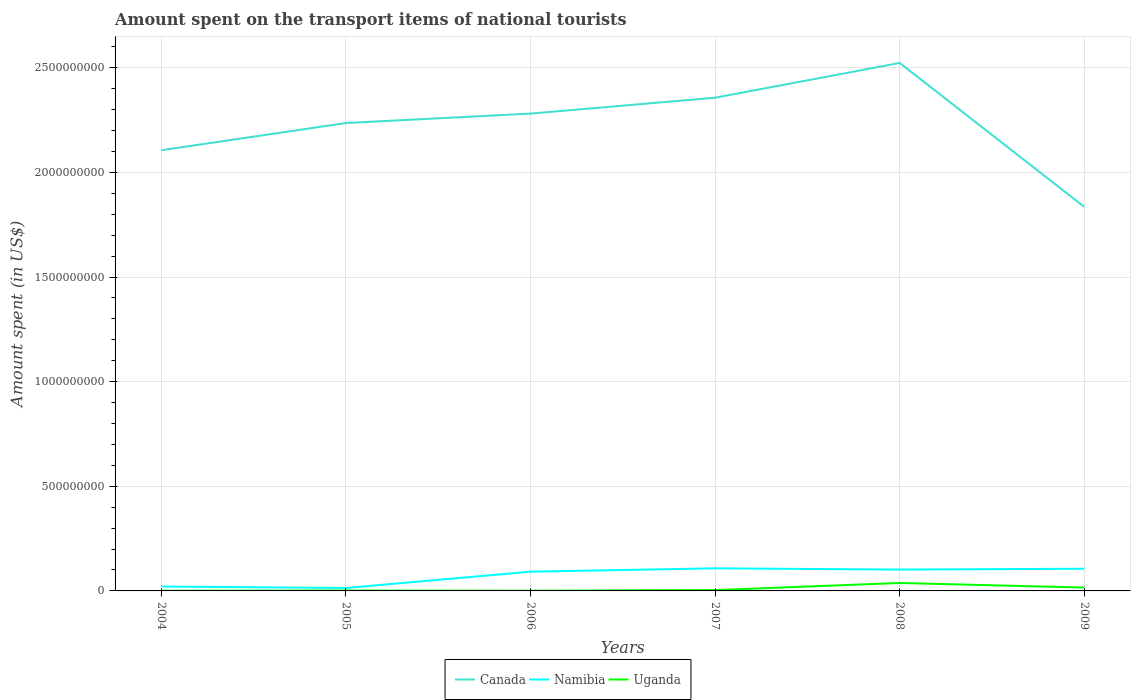Is the number of lines equal to the number of legend labels?
Offer a very short reply. Yes. In which year was the amount spent on the transport items of national tourists in Namibia maximum?
Offer a very short reply. 2005. What is the total amount spent on the transport items of national tourists in Namibia in the graph?
Make the answer very short. -4.00e+06. What is the difference between the highest and the second highest amount spent on the transport items of national tourists in Uganda?
Ensure brevity in your answer.  3.70e+07. What is the difference between two consecutive major ticks on the Y-axis?
Your answer should be compact. 5.00e+08. Are the values on the major ticks of Y-axis written in scientific E-notation?
Make the answer very short. No. Does the graph contain grids?
Offer a terse response. Yes. What is the title of the graph?
Offer a very short reply. Amount spent on the transport items of national tourists. Does "Kazakhstan" appear as one of the legend labels in the graph?
Provide a short and direct response. No. What is the label or title of the X-axis?
Make the answer very short. Years. What is the label or title of the Y-axis?
Your answer should be very brief. Amount spent (in US$). What is the Amount spent (in US$) of Canada in 2004?
Ensure brevity in your answer.  2.11e+09. What is the Amount spent (in US$) in Namibia in 2004?
Give a very brief answer. 2.10e+07. What is the Amount spent (in US$) of Canada in 2005?
Provide a succinct answer. 2.24e+09. What is the Amount spent (in US$) of Namibia in 2005?
Ensure brevity in your answer.  1.40e+07. What is the Amount spent (in US$) in Canada in 2006?
Make the answer very short. 2.28e+09. What is the Amount spent (in US$) in Namibia in 2006?
Provide a short and direct response. 9.20e+07. What is the Amount spent (in US$) of Uganda in 2006?
Offer a very short reply. 1.00e+06. What is the Amount spent (in US$) of Canada in 2007?
Give a very brief answer. 2.36e+09. What is the Amount spent (in US$) of Namibia in 2007?
Your answer should be compact. 1.08e+08. What is the Amount spent (in US$) of Uganda in 2007?
Offer a terse response. 4.00e+06. What is the Amount spent (in US$) of Canada in 2008?
Your response must be concise. 2.52e+09. What is the Amount spent (in US$) in Namibia in 2008?
Provide a short and direct response. 1.02e+08. What is the Amount spent (in US$) of Uganda in 2008?
Provide a short and direct response. 3.80e+07. What is the Amount spent (in US$) in Canada in 2009?
Offer a very short reply. 1.84e+09. What is the Amount spent (in US$) in Namibia in 2009?
Offer a very short reply. 1.06e+08. What is the Amount spent (in US$) in Uganda in 2009?
Offer a terse response. 1.60e+07. Across all years, what is the maximum Amount spent (in US$) in Canada?
Your response must be concise. 2.52e+09. Across all years, what is the maximum Amount spent (in US$) in Namibia?
Your answer should be compact. 1.08e+08. Across all years, what is the maximum Amount spent (in US$) of Uganda?
Keep it short and to the point. 3.80e+07. Across all years, what is the minimum Amount spent (in US$) in Canada?
Ensure brevity in your answer.  1.84e+09. Across all years, what is the minimum Amount spent (in US$) in Namibia?
Provide a succinct answer. 1.40e+07. Across all years, what is the minimum Amount spent (in US$) of Uganda?
Ensure brevity in your answer.  1.00e+06. What is the total Amount spent (in US$) of Canada in the graph?
Provide a succinct answer. 1.33e+1. What is the total Amount spent (in US$) in Namibia in the graph?
Your answer should be very brief. 4.43e+08. What is the total Amount spent (in US$) in Uganda in the graph?
Give a very brief answer. 6.20e+07. What is the difference between the Amount spent (in US$) of Canada in 2004 and that in 2005?
Give a very brief answer. -1.30e+08. What is the difference between the Amount spent (in US$) in Canada in 2004 and that in 2006?
Offer a very short reply. -1.75e+08. What is the difference between the Amount spent (in US$) of Namibia in 2004 and that in 2006?
Offer a terse response. -7.10e+07. What is the difference between the Amount spent (in US$) in Uganda in 2004 and that in 2006?
Keep it short and to the point. 0. What is the difference between the Amount spent (in US$) in Canada in 2004 and that in 2007?
Provide a succinct answer. -2.51e+08. What is the difference between the Amount spent (in US$) of Namibia in 2004 and that in 2007?
Offer a terse response. -8.70e+07. What is the difference between the Amount spent (in US$) of Canada in 2004 and that in 2008?
Your answer should be compact. -4.17e+08. What is the difference between the Amount spent (in US$) of Namibia in 2004 and that in 2008?
Keep it short and to the point. -8.10e+07. What is the difference between the Amount spent (in US$) in Uganda in 2004 and that in 2008?
Provide a short and direct response. -3.70e+07. What is the difference between the Amount spent (in US$) of Canada in 2004 and that in 2009?
Provide a succinct answer. 2.71e+08. What is the difference between the Amount spent (in US$) in Namibia in 2004 and that in 2009?
Keep it short and to the point. -8.50e+07. What is the difference between the Amount spent (in US$) in Uganda in 2004 and that in 2009?
Your answer should be compact. -1.50e+07. What is the difference between the Amount spent (in US$) in Canada in 2005 and that in 2006?
Your response must be concise. -4.50e+07. What is the difference between the Amount spent (in US$) in Namibia in 2005 and that in 2006?
Give a very brief answer. -7.80e+07. What is the difference between the Amount spent (in US$) of Canada in 2005 and that in 2007?
Provide a short and direct response. -1.21e+08. What is the difference between the Amount spent (in US$) in Namibia in 2005 and that in 2007?
Ensure brevity in your answer.  -9.40e+07. What is the difference between the Amount spent (in US$) of Canada in 2005 and that in 2008?
Give a very brief answer. -2.87e+08. What is the difference between the Amount spent (in US$) in Namibia in 2005 and that in 2008?
Make the answer very short. -8.80e+07. What is the difference between the Amount spent (in US$) of Uganda in 2005 and that in 2008?
Offer a very short reply. -3.60e+07. What is the difference between the Amount spent (in US$) in Canada in 2005 and that in 2009?
Offer a terse response. 4.01e+08. What is the difference between the Amount spent (in US$) in Namibia in 2005 and that in 2009?
Keep it short and to the point. -9.20e+07. What is the difference between the Amount spent (in US$) of Uganda in 2005 and that in 2009?
Offer a very short reply. -1.40e+07. What is the difference between the Amount spent (in US$) in Canada in 2006 and that in 2007?
Make the answer very short. -7.60e+07. What is the difference between the Amount spent (in US$) of Namibia in 2006 and that in 2007?
Ensure brevity in your answer.  -1.60e+07. What is the difference between the Amount spent (in US$) in Uganda in 2006 and that in 2007?
Give a very brief answer. -3.00e+06. What is the difference between the Amount spent (in US$) of Canada in 2006 and that in 2008?
Offer a terse response. -2.42e+08. What is the difference between the Amount spent (in US$) of Namibia in 2006 and that in 2008?
Provide a succinct answer. -1.00e+07. What is the difference between the Amount spent (in US$) of Uganda in 2006 and that in 2008?
Ensure brevity in your answer.  -3.70e+07. What is the difference between the Amount spent (in US$) of Canada in 2006 and that in 2009?
Ensure brevity in your answer.  4.46e+08. What is the difference between the Amount spent (in US$) of Namibia in 2006 and that in 2009?
Give a very brief answer. -1.40e+07. What is the difference between the Amount spent (in US$) of Uganda in 2006 and that in 2009?
Ensure brevity in your answer.  -1.50e+07. What is the difference between the Amount spent (in US$) of Canada in 2007 and that in 2008?
Your response must be concise. -1.66e+08. What is the difference between the Amount spent (in US$) of Namibia in 2007 and that in 2008?
Your answer should be compact. 6.00e+06. What is the difference between the Amount spent (in US$) in Uganda in 2007 and that in 2008?
Make the answer very short. -3.40e+07. What is the difference between the Amount spent (in US$) in Canada in 2007 and that in 2009?
Keep it short and to the point. 5.22e+08. What is the difference between the Amount spent (in US$) in Uganda in 2007 and that in 2009?
Make the answer very short. -1.20e+07. What is the difference between the Amount spent (in US$) of Canada in 2008 and that in 2009?
Keep it short and to the point. 6.88e+08. What is the difference between the Amount spent (in US$) of Uganda in 2008 and that in 2009?
Your answer should be compact. 2.20e+07. What is the difference between the Amount spent (in US$) of Canada in 2004 and the Amount spent (in US$) of Namibia in 2005?
Provide a short and direct response. 2.09e+09. What is the difference between the Amount spent (in US$) of Canada in 2004 and the Amount spent (in US$) of Uganda in 2005?
Provide a short and direct response. 2.10e+09. What is the difference between the Amount spent (in US$) of Namibia in 2004 and the Amount spent (in US$) of Uganda in 2005?
Keep it short and to the point. 1.90e+07. What is the difference between the Amount spent (in US$) in Canada in 2004 and the Amount spent (in US$) in Namibia in 2006?
Provide a succinct answer. 2.01e+09. What is the difference between the Amount spent (in US$) of Canada in 2004 and the Amount spent (in US$) of Uganda in 2006?
Your answer should be very brief. 2.10e+09. What is the difference between the Amount spent (in US$) of Namibia in 2004 and the Amount spent (in US$) of Uganda in 2006?
Provide a short and direct response. 2.00e+07. What is the difference between the Amount spent (in US$) of Canada in 2004 and the Amount spent (in US$) of Namibia in 2007?
Provide a succinct answer. 2.00e+09. What is the difference between the Amount spent (in US$) in Canada in 2004 and the Amount spent (in US$) in Uganda in 2007?
Provide a short and direct response. 2.10e+09. What is the difference between the Amount spent (in US$) in Namibia in 2004 and the Amount spent (in US$) in Uganda in 2007?
Your answer should be compact. 1.70e+07. What is the difference between the Amount spent (in US$) in Canada in 2004 and the Amount spent (in US$) in Namibia in 2008?
Your answer should be very brief. 2.00e+09. What is the difference between the Amount spent (in US$) in Canada in 2004 and the Amount spent (in US$) in Uganda in 2008?
Your response must be concise. 2.07e+09. What is the difference between the Amount spent (in US$) of Namibia in 2004 and the Amount spent (in US$) of Uganda in 2008?
Give a very brief answer. -1.70e+07. What is the difference between the Amount spent (in US$) of Canada in 2004 and the Amount spent (in US$) of Namibia in 2009?
Your answer should be compact. 2.00e+09. What is the difference between the Amount spent (in US$) of Canada in 2004 and the Amount spent (in US$) of Uganda in 2009?
Make the answer very short. 2.09e+09. What is the difference between the Amount spent (in US$) of Namibia in 2004 and the Amount spent (in US$) of Uganda in 2009?
Your answer should be compact. 5.00e+06. What is the difference between the Amount spent (in US$) in Canada in 2005 and the Amount spent (in US$) in Namibia in 2006?
Keep it short and to the point. 2.14e+09. What is the difference between the Amount spent (in US$) of Canada in 2005 and the Amount spent (in US$) of Uganda in 2006?
Make the answer very short. 2.24e+09. What is the difference between the Amount spent (in US$) of Namibia in 2005 and the Amount spent (in US$) of Uganda in 2006?
Make the answer very short. 1.30e+07. What is the difference between the Amount spent (in US$) in Canada in 2005 and the Amount spent (in US$) in Namibia in 2007?
Provide a succinct answer. 2.13e+09. What is the difference between the Amount spent (in US$) in Canada in 2005 and the Amount spent (in US$) in Uganda in 2007?
Offer a terse response. 2.23e+09. What is the difference between the Amount spent (in US$) of Namibia in 2005 and the Amount spent (in US$) of Uganda in 2007?
Keep it short and to the point. 1.00e+07. What is the difference between the Amount spent (in US$) of Canada in 2005 and the Amount spent (in US$) of Namibia in 2008?
Your answer should be compact. 2.13e+09. What is the difference between the Amount spent (in US$) in Canada in 2005 and the Amount spent (in US$) in Uganda in 2008?
Ensure brevity in your answer.  2.20e+09. What is the difference between the Amount spent (in US$) of Namibia in 2005 and the Amount spent (in US$) of Uganda in 2008?
Offer a terse response. -2.40e+07. What is the difference between the Amount spent (in US$) in Canada in 2005 and the Amount spent (in US$) in Namibia in 2009?
Offer a terse response. 2.13e+09. What is the difference between the Amount spent (in US$) of Canada in 2005 and the Amount spent (in US$) of Uganda in 2009?
Your response must be concise. 2.22e+09. What is the difference between the Amount spent (in US$) in Namibia in 2005 and the Amount spent (in US$) in Uganda in 2009?
Give a very brief answer. -2.00e+06. What is the difference between the Amount spent (in US$) of Canada in 2006 and the Amount spent (in US$) of Namibia in 2007?
Your answer should be very brief. 2.17e+09. What is the difference between the Amount spent (in US$) of Canada in 2006 and the Amount spent (in US$) of Uganda in 2007?
Your response must be concise. 2.28e+09. What is the difference between the Amount spent (in US$) of Namibia in 2006 and the Amount spent (in US$) of Uganda in 2007?
Provide a short and direct response. 8.80e+07. What is the difference between the Amount spent (in US$) in Canada in 2006 and the Amount spent (in US$) in Namibia in 2008?
Keep it short and to the point. 2.18e+09. What is the difference between the Amount spent (in US$) of Canada in 2006 and the Amount spent (in US$) of Uganda in 2008?
Ensure brevity in your answer.  2.24e+09. What is the difference between the Amount spent (in US$) in Namibia in 2006 and the Amount spent (in US$) in Uganda in 2008?
Your response must be concise. 5.40e+07. What is the difference between the Amount spent (in US$) in Canada in 2006 and the Amount spent (in US$) in Namibia in 2009?
Offer a terse response. 2.18e+09. What is the difference between the Amount spent (in US$) in Canada in 2006 and the Amount spent (in US$) in Uganda in 2009?
Offer a very short reply. 2.26e+09. What is the difference between the Amount spent (in US$) in Namibia in 2006 and the Amount spent (in US$) in Uganda in 2009?
Keep it short and to the point. 7.60e+07. What is the difference between the Amount spent (in US$) of Canada in 2007 and the Amount spent (in US$) of Namibia in 2008?
Keep it short and to the point. 2.26e+09. What is the difference between the Amount spent (in US$) in Canada in 2007 and the Amount spent (in US$) in Uganda in 2008?
Your response must be concise. 2.32e+09. What is the difference between the Amount spent (in US$) of Namibia in 2007 and the Amount spent (in US$) of Uganda in 2008?
Offer a terse response. 7.00e+07. What is the difference between the Amount spent (in US$) in Canada in 2007 and the Amount spent (in US$) in Namibia in 2009?
Provide a succinct answer. 2.25e+09. What is the difference between the Amount spent (in US$) in Canada in 2007 and the Amount spent (in US$) in Uganda in 2009?
Provide a succinct answer. 2.34e+09. What is the difference between the Amount spent (in US$) of Namibia in 2007 and the Amount spent (in US$) of Uganda in 2009?
Provide a short and direct response. 9.20e+07. What is the difference between the Amount spent (in US$) of Canada in 2008 and the Amount spent (in US$) of Namibia in 2009?
Make the answer very short. 2.42e+09. What is the difference between the Amount spent (in US$) in Canada in 2008 and the Amount spent (in US$) in Uganda in 2009?
Provide a short and direct response. 2.51e+09. What is the difference between the Amount spent (in US$) of Namibia in 2008 and the Amount spent (in US$) of Uganda in 2009?
Your answer should be very brief. 8.60e+07. What is the average Amount spent (in US$) of Canada per year?
Your answer should be compact. 2.22e+09. What is the average Amount spent (in US$) in Namibia per year?
Your response must be concise. 7.38e+07. What is the average Amount spent (in US$) in Uganda per year?
Your answer should be compact. 1.03e+07. In the year 2004, what is the difference between the Amount spent (in US$) in Canada and Amount spent (in US$) in Namibia?
Make the answer very short. 2.08e+09. In the year 2004, what is the difference between the Amount spent (in US$) in Canada and Amount spent (in US$) in Uganda?
Provide a succinct answer. 2.10e+09. In the year 2004, what is the difference between the Amount spent (in US$) of Namibia and Amount spent (in US$) of Uganda?
Make the answer very short. 2.00e+07. In the year 2005, what is the difference between the Amount spent (in US$) of Canada and Amount spent (in US$) of Namibia?
Provide a short and direct response. 2.22e+09. In the year 2005, what is the difference between the Amount spent (in US$) in Canada and Amount spent (in US$) in Uganda?
Your answer should be very brief. 2.23e+09. In the year 2006, what is the difference between the Amount spent (in US$) of Canada and Amount spent (in US$) of Namibia?
Provide a short and direct response. 2.19e+09. In the year 2006, what is the difference between the Amount spent (in US$) of Canada and Amount spent (in US$) of Uganda?
Ensure brevity in your answer.  2.28e+09. In the year 2006, what is the difference between the Amount spent (in US$) in Namibia and Amount spent (in US$) in Uganda?
Your response must be concise. 9.10e+07. In the year 2007, what is the difference between the Amount spent (in US$) in Canada and Amount spent (in US$) in Namibia?
Your answer should be very brief. 2.25e+09. In the year 2007, what is the difference between the Amount spent (in US$) of Canada and Amount spent (in US$) of Uganda?
Make the answer very short. 2.35e+09. In the year 2007, what is the difference between the Amount spent (in US$) in Namibia and Amount spent (in US$) in Uganda?
Keep it short and to the point. 1.04e+08. In the year 2008, what is the difference between the Amount spent (in US$) of Canada and Amount spent (in US$) of Namibia?
Your answer should be compact. 2.42e+09. In the year 2008, what is the difference between the Amount spent (in US$) of Canada and Amount spent (in US$) of Uganda?
Your answer should be very brief. 2.48e+09. In the year 2008, what is the difference between the Amount spent (in US$) in Namibia and Amount spent (in US$) in Uganda?
Your answer should be compact. 6.40e+07. In the year 2009, what is the difference between the Amount spent (in US$) in Canada and Amount spent (in US$) in Namibia?
Give a very brief answer. 1.73e+09. In the year 2009, what is the difference between the Amount spent (in US$) of Canada and Amount spent (in US$) of Uganda?
Your answer should be compact. 1.82e+09. In the year 2009, what is the difference between the Amount spent (in US$) of Namibia and Amount spent (in US$) of Uganda?
Your response must be concise. 9.00e+07. What is the ratio of the Amount spent (in US$) in Canada in 2004 to that in 2005?
Offer a terse response. 0.94. What is the ratio of the Amount spent (in US$) in Canada in 2004 to that in 2006?
Your response must be concise. 0.92. What is the ratio of the Amount spent (in US$) in Namibia in 2004 to that in 2006?
Ensure brevity in your answer.  0.23. What is the ratio of the Amount spent (in US$) in Canada in 2004 to that in 2007?
Make the answer very short. 0.89. What is the ratio of the Amount spent (in US$) in Namibia in 2004 to that in 2007?
Offer a very short reply. 0.19. What is the ratio of the Amount spent (in US$) of Canada in 2004 to that in 2008?
Your answer should be very brief. 0.83. What is the ratio of the Amount spent (in US$) of Namibia in 2004 to that in 2008?
Your answer should be compact. 0.21. What is the ratio of the Amount spent (in US$) of Uganda in 2004 to that in 2008?
Your answer should be very brief. 0.03. What is the ratio of the Amount spent (in US$) in Canada in 2004 to that in 2009?
Offer a terse response. 1.15. What is the ratio of the Amount spent (in US$) in Namibia in 2004 to that in 2009?
Offer a very short reply. 0.2. What is the ratio of the Amount spent (in US$) of Uganda in 2004 to that in 2009?
Provide a short and direct response. 0.06. What is the ratio of the Amount spent (in US$) in Canada in 2005 to that in 2006?
Your response must be concise. 0.98. What is the ratio of the Amount spent (in US$) of Namibia in 2005 to that in 2006?
Make the answer very short. 0.15. What is the ratio of the Amount spent (in US$) in Uganda in 2005 to that in 2006?
Offer a terse response. 2. What is the ratio of the Amount spent (in US$) in Canada in 2005 to that in 2007?
Make the answer very short. 0.95. What is the ratio of the Amount spent (in US$) in Namibia in 2005 to that in 2007?
Give a very brief answer. 0.13. What is the ratio of the Amount spent (in US$) of Canada in 2005 to that in 2008?
Your response must be concise. 0.89. What is the ratio of the Amount spent (in US$) in Namibia in 2005 to that in 2008?
Your answer should be very brief. 0.14. What is the ratio of the Amount spent (in US$) of Uganda in 2005 to that in 2008?
Offer a very short reply. 0.05. What is the ratio of the Amount spent (in US$) in Canada in 2005 to that in 2009?
Your answer should be compact. 1.22. What is the ratio of the Amount spent (in US$) of Namibia in 2005 to that in 2009?
Keep it short and to the point. 0.13. What is the ratio of the Amount spent (in US$) in Canada in 2006 to that in 2007?
Offer a very short reply. 0.97. What is the ratio of the Amount spent (in US$) in Namibia in 2006 to that in 2007?
Provide a short and direct response. 0.85. What is the ratio of the Amount spent (in US$) in Uganda in 2006 to that in 2007?
Provide a succinct answer. 0.25. What is the ratio of the Amount spent (in US$) in Canada in 2006 to that in 2008?
Ensure brevity in your answer.  0.9. What is the ratio of the Amount spent (in US$) of Namibia in 2006 to that in 2008?
Give a very brief answer. 0.9. What is the ratio of the Amount spent (in US$) in Uganda in 2006 to that in 2008?
Give a very brief answer. 0.03. What is the ratio of the Amount spent (in US$) of Canada in 2006 to that in 2009?
Ensure brevity in your answer.  1.24. What is the ratio of the Amount spent (in US$) in Namibia in 2006 to that in 2009?
Offer a very short reply. 0.87. What is the ratio of the Amount spent (in US$) of Uganda in 2006 to that in 2009?
Provide a succinct answer. 0.06. What is the ratio of the Amount spent (in US$) of Canada in 2007 to that in 2008?
Keep it short and to the point. 0.93. What is the ratio of the Amount spent (in US$) in Namibia in 2007 to that in 2008?
Ensure brevity in your answer.  1.06. What is the ratio of the Amount spent (in US$) of Uganda in 2007 to that in 2008?
Provide a short and direct response. 0.11. What is the ratio of the Amount spent (in US$) of Canada in 2007 to that in 2009?
Provide a succinct answer. 1.28. What is the ratio of the Amount spent (in US$) in Namibia in 2007 to that in 2009?
Provide a succinct answer. 1.02. What is the ratio of the Amount spent (in US$) of Uganda in 2007 to that in 2009?
Ensure brevity in your answer.  0.25. What is the ratio of the Amount spent (in US$) in Canada in 2008 to that in 2009?
Offer a very short reply. 1.37. What is the ratio of the Amount spent (in US$) of Namibia in 2008 to that in 2009?
Provide a succinct answer. 0.96. What is the ratio of the Amount spent (in US$) of Uganda in 2008 to that in 2009?
Ensure brevity in your answer.  2.38. What is the difference between the highest and the second highest Amount spent (in US$) of Canada?
Offer a terse response. 1.66e+08. What is the difference between the highest and the second highest Amount spent (in US$) of Namibia?
Give a very brief answer. 2.00e+06. What is the difference between the highest and the second highest Amount spent (in US$) of Uganda?
Provide a succinct answer. 2.20e+07. What is the difference between the highest and the lowest Amount spent (in US$) in Canada?
Offer a very short reply. 6.88e+08. What is the difference between the highest and the lowest Amount spent (in US$) of Namibia?
Ensure brevity in your answer.  9.40e+07. What is the difference between the highest and the lowest Amount spent (in US$) in Uganda?
Offer a terse response. 3.70e+07. 